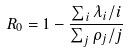Convert formula to latex. <formula><loc_0><loc_0><loc_500><loc_500>R _ { 0 } = 1 - \frac { \sum _ { i } \lambda _ { i } / i } { \sum _ { j } \rho _ { j } / j }</formula> 